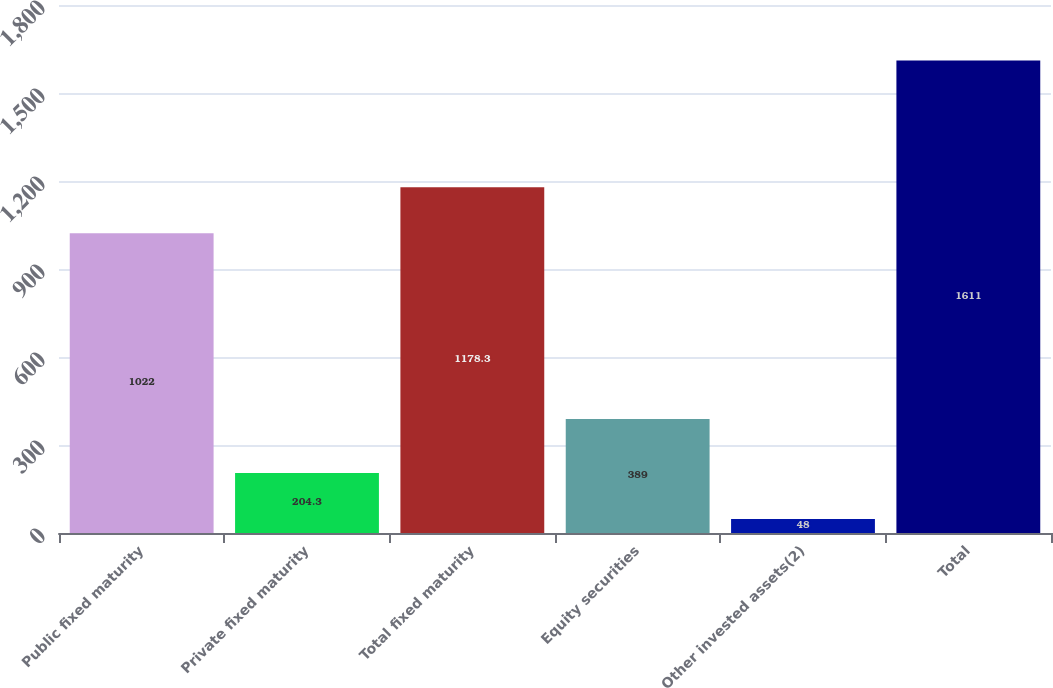Convert chart. <chart><loc_0><loc_0><loc_500><loc_500><bar_chart><fcel>Public fixed maturity<fcel>Private fixed maturity<fcel>Total fixed maturity<fcel>Equity securities<fcel>Other invested assets(2)<fcel>Total<nl><fcel>1022<fcel>204.3<fcel>1178.3<fcel>389<fcel>48<fcel>1611<nl></chart> 